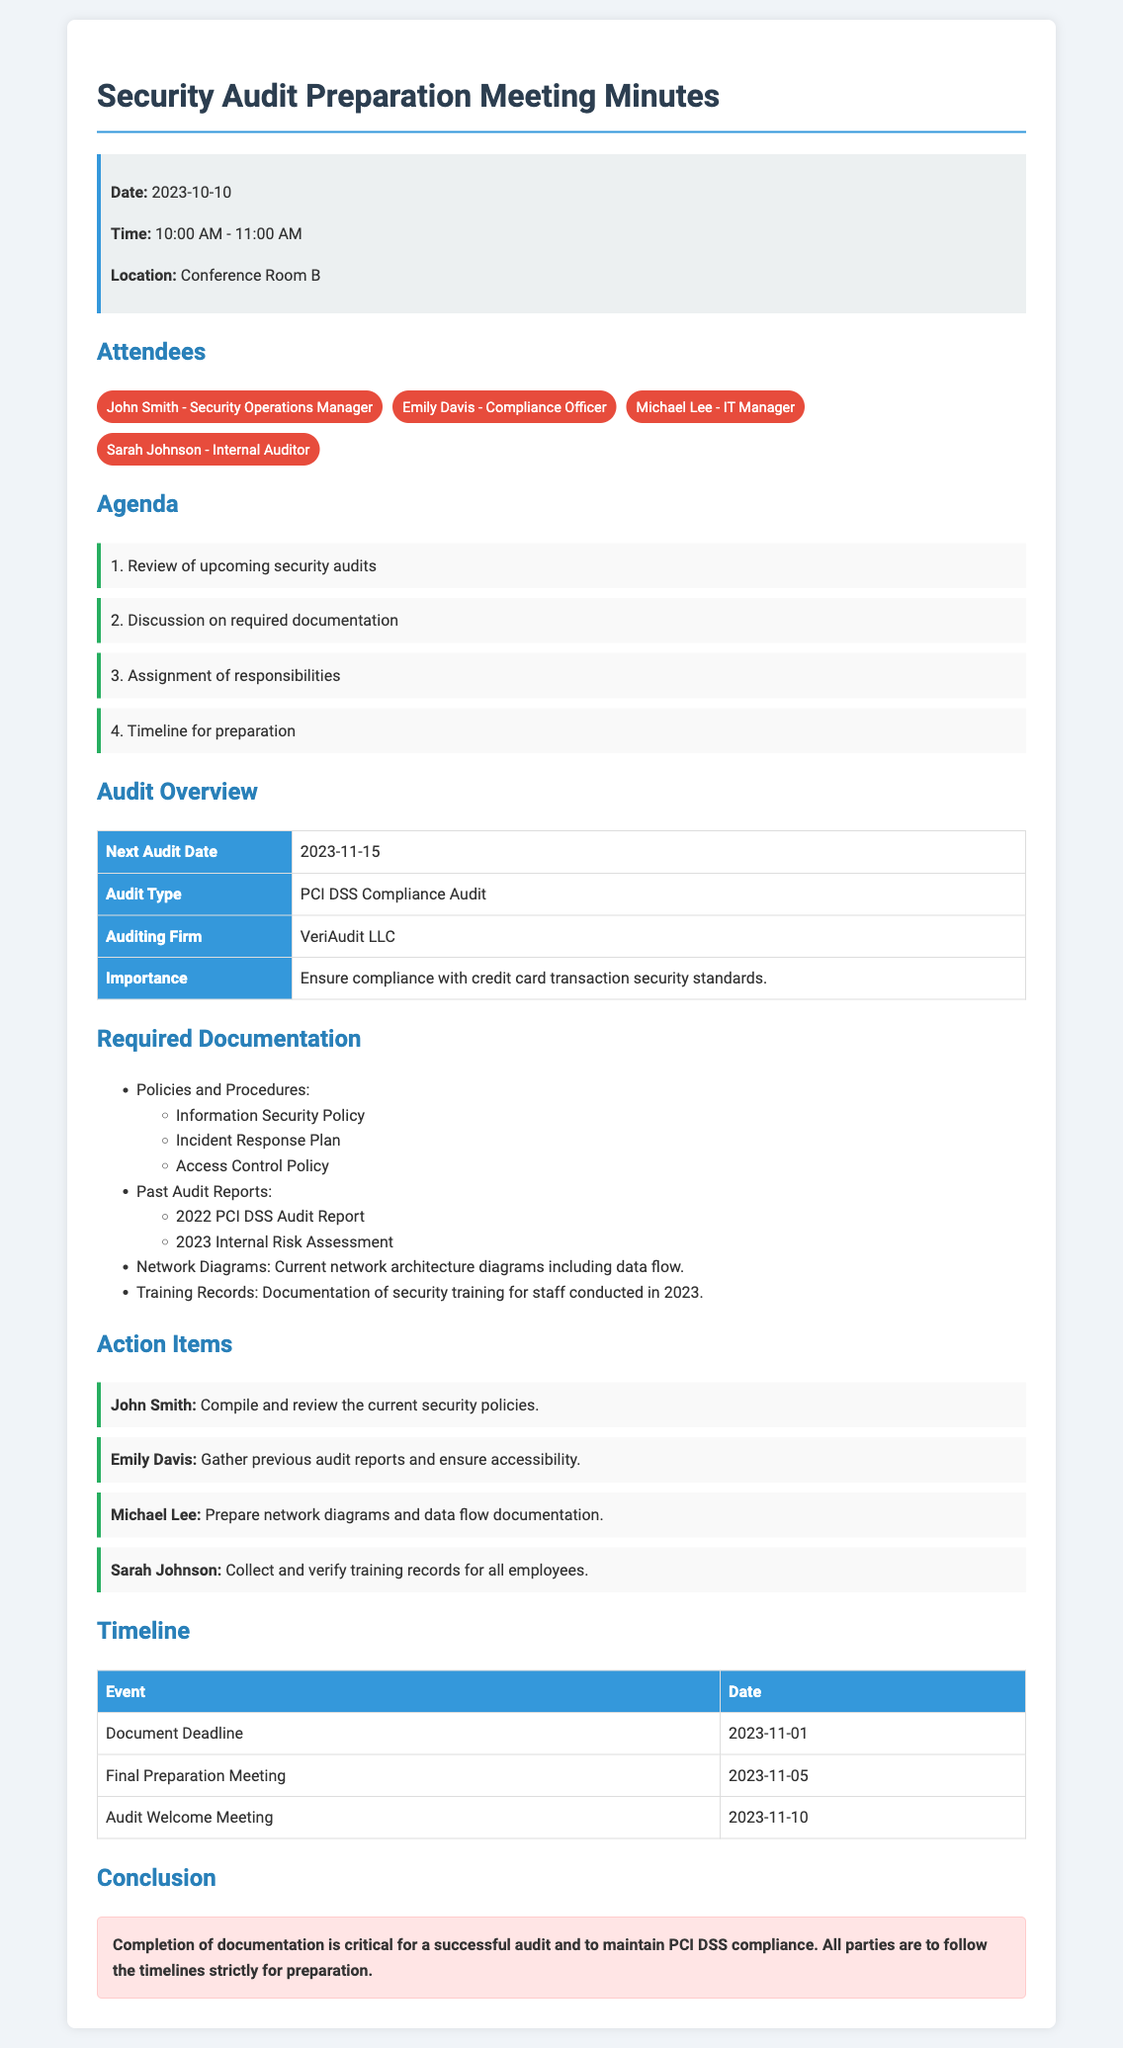What is the date of the next audit? The next audit date is clearly stated in the Audit Overview section of the document.
Answer: 2023-11-15 Who is the auditing firm? The auditing firm is mentioned in the Audit Overview section and specifically identified.
Answer: VeriAudit LLC What is the importance of the PCI DSS Compliance Audit? The importance is described in the Audit Overview section, detailing the reason for the audit.
Answer: Ensure compliance with credit card transaction security standards What is the document deadline? The document deadline is provided in the Timeline section, indicating when documents must be completed.
Answer: 2023-11-01 Which document requires the preparation of network diagrams? The required documentation list includes a specific item related to network architecture.
Answer: Network Diagrams What are John Smith's responsibilities? John Smith's action item is outlined clearly, detailing his responsibility in the preparation process.
Answer: Compile and review the current security policies What is the date of the Final Preparation Meeting? The date for this meeting is provided in the Timeline section of the document.
Answer: 2023-11-05 How many attendees were there? The attendees list details the total number of individuals present during the meeting.
Answer: 4 What is the title of the meeting minutes? The title is stated at the top of the document, indicating the focus of the meeting.
Answer: Security Audit Preparation Meeting Minutes What type of audit is being conducted? The type of audit is indicated in the Audit Overview section to describe the nature of the audit.
Answer: PCI DSS Compliance Audit 